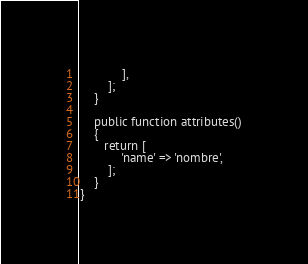Convert code to text. <code><loc_0><loc_0><loc_500><loc_500><_PHP_>            ],
        ];
    }

    public function attributes()
    {
       return [
            'name' => 'nombre',
        ];
    }
}
</code> 